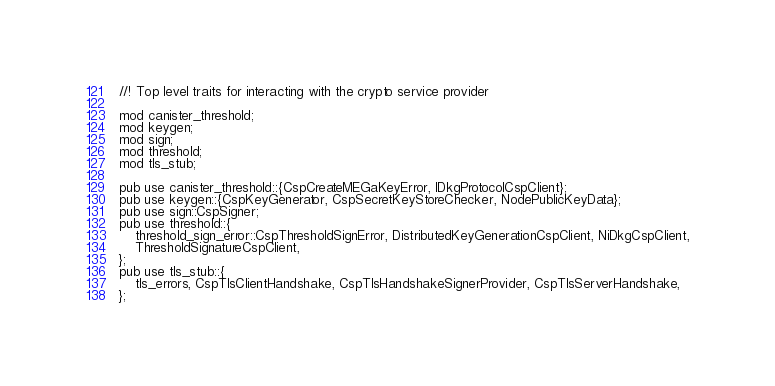Convert code to text. <code><loc_0><loc_0><loc_500><loc_500><_Rust_>//! Top level traits for interacting with the crypto service provider

mod canister_threshold;
mod keygen;
mod sign;
mod threshold;
mod tls_stub;

pub use canister_threshold::{CspCreateMEGaKeyError, IDkgProtocolCspClient};
pub use keygen::{CspKeyGenerator, CspSecretKeyStoreChecker, NodePublicKeyData};
pub use sign::CspSigner;
pub use threshold::{
    threshold_sign_error::CspThresholdSignError, DistributedKeyGenerationCspClient, NiDkgCspClient,
    ThresholdSignatureCspClient,
};
pub use tls_stub::{
    tls_errors, CspTlsClientHandshake, CspTlsHandshakeSignerProvider, CspTlsServerHandshake,
};
</code> 